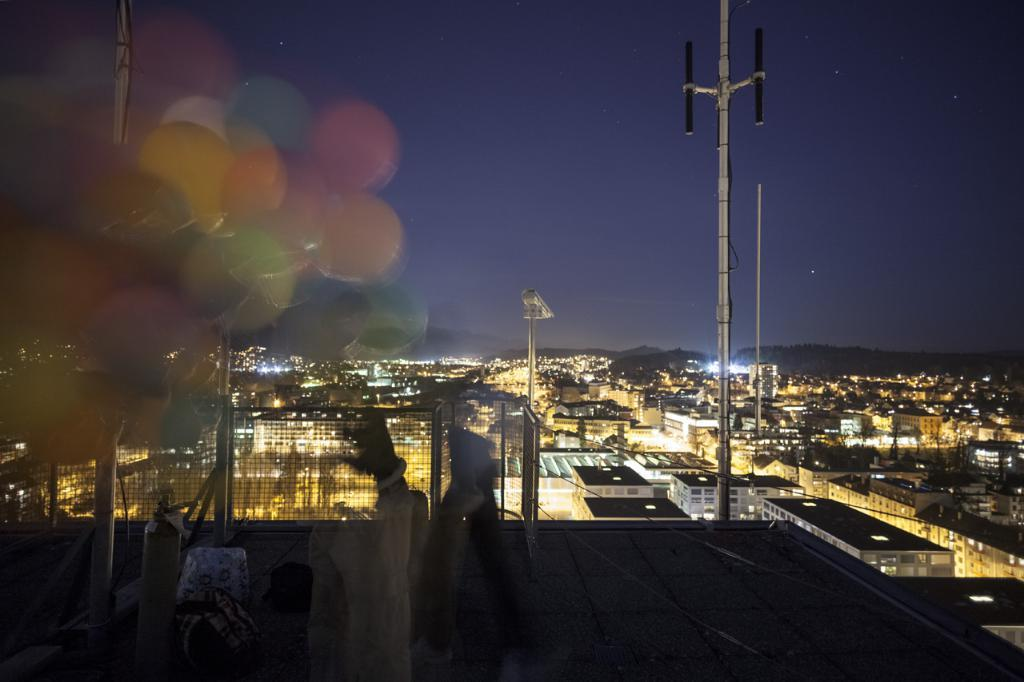What type of decorations are present in the image? There are multi-color balloons in the image. What can be seen in the background of the image? There are poles and buildings visible in the background of the image. What other decorative elements are present in the image? There are multi-color lights in the image. What is the color of the sky in the image? The sky is blue and black in color. Can you see the lead in the ocean in the image? There is no ocean or lead present in the image. Is there a church visible in the image? There is no church present in the image. 